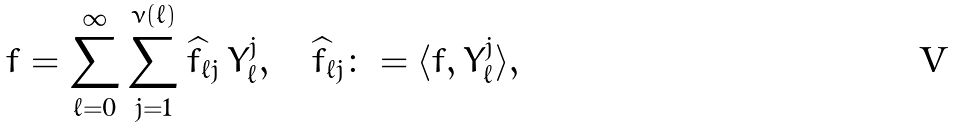Convert formula to latex. <formula><loc_0><loc_0><loc_500><loc_500>f = \sum _ { \ell = 0 } ^ { \infty } \sum _ { j = 1 } ^ { \nu ( \ell ) } \widehat { f } _ { \ell j } \, Y _ { \ell } ^ { j } , \quad \widehat { f } _ { \ell j } \colon = \langle f , Y _ { \ell } ^ { j } \rangle ,</formula> 